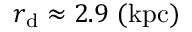<formula> <loc_0><loc_0><loc_500><loc_500>r _ { d } \approx 2 . 9 ( k p c )</formula> 